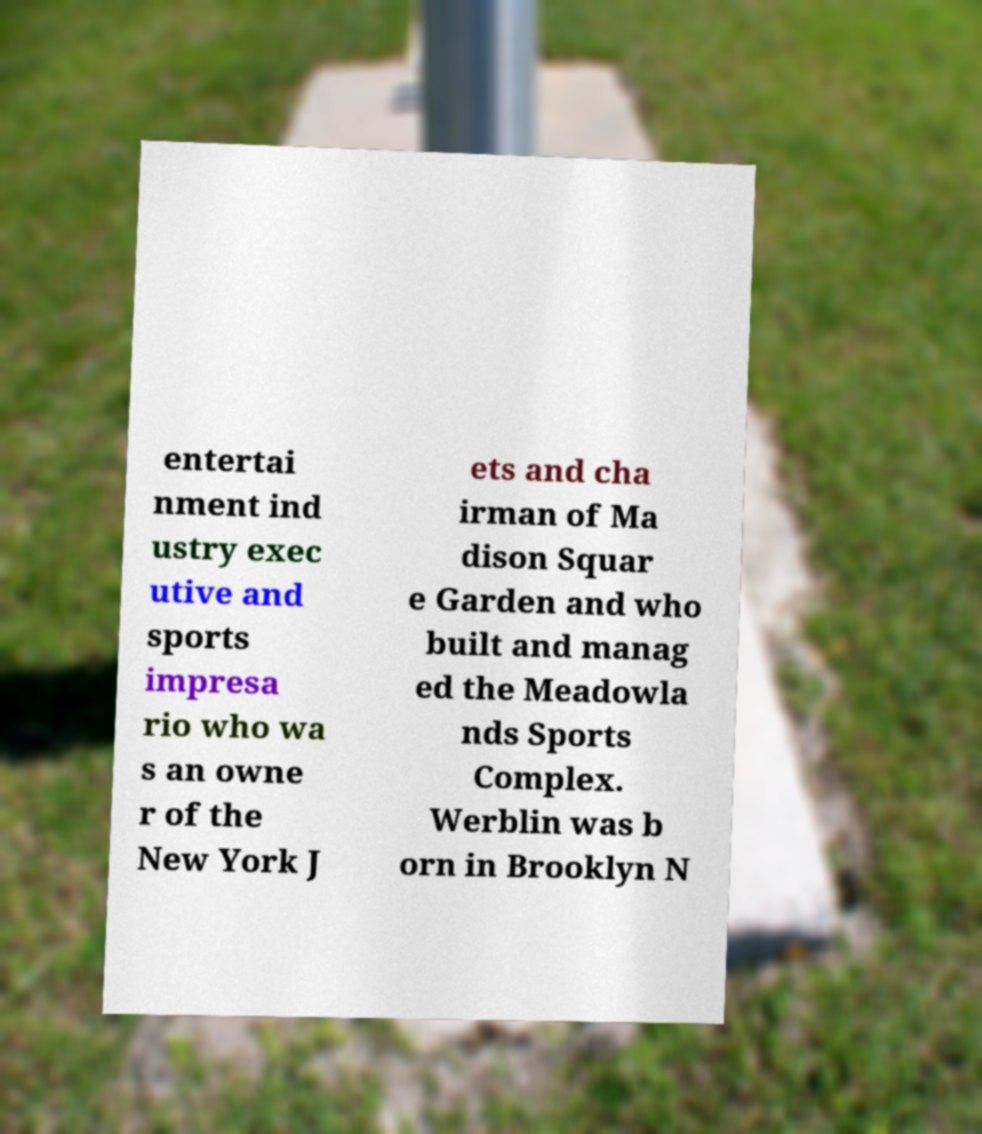Could you assist in decoding the text presented in this image and type it out clearly? entertai nment ind ustry exec utive and sports impresa rio who wa s an owne r of the New York J ets and cha irman of Ma dison Squar e Garden and who built and manag ed the Meadowla nds Sports Complex. Werblin was b orn in Brooklyn N 